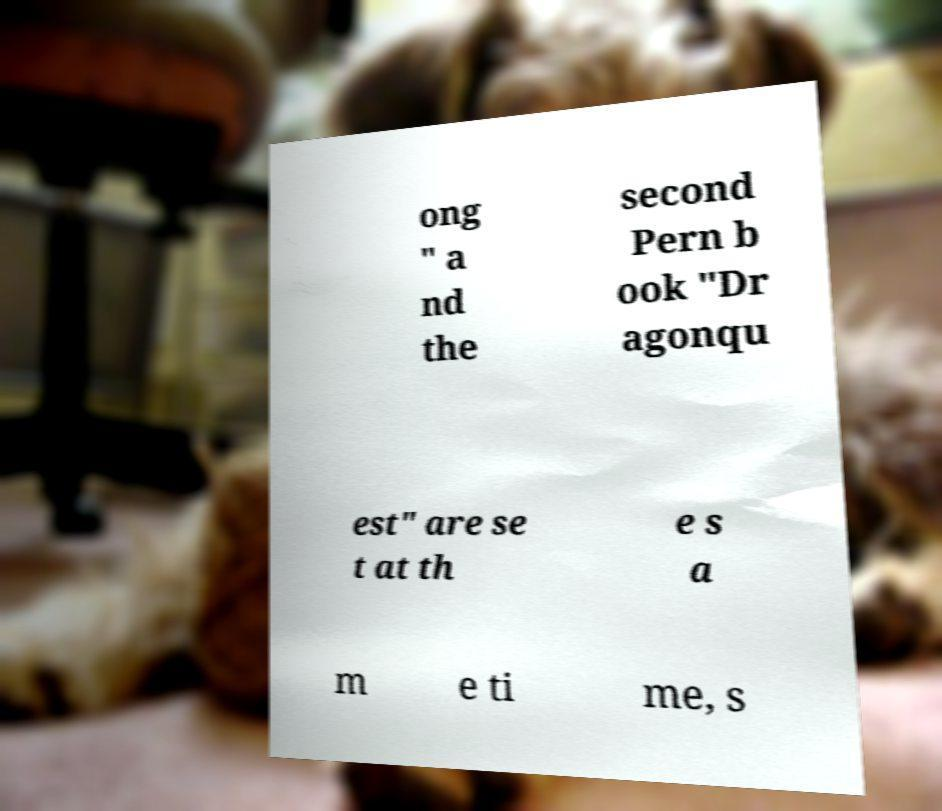Could you extract and type out the text from this image? ong " a nd the second Pern b ook "Dr agonqu est" are se t at th e s a m e ti me, s 